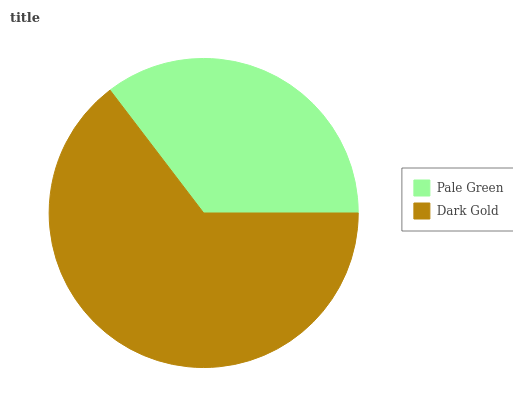Is Pale Green the minimum?
Answer yes or no. Yes. Is Dark Gold the maximum?
Answer yes or no. Yes. Is Dark Gold the minimum?
Answer yes or no. No. Is Dark Gold greater than Pale Green?
Answer yes or no. Yes. Is Pale Green less than Dark Gold?
Answer yes or no. Yes. Is Pale Green greater than Dark Gold?
Answer yes or no. No. Is Dark Gold less than Pale Green?
Answer yes or no. No. Is Dark Gold the high median?
Answer yes or no. Yes. Is Pale Green the low median?
Answer yes or no. Yes. Is Pale Green the high median?
Answer yes or no. No. Is Dark Gold the low median?
Answer yes or no. No. 